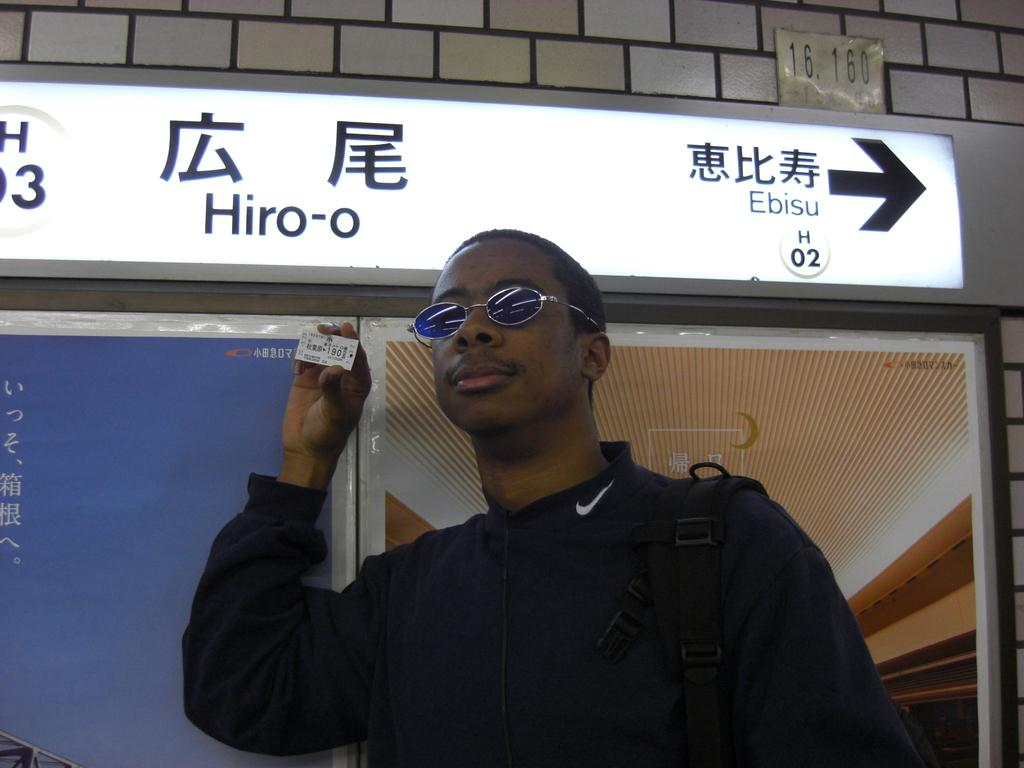Who or what is present in the image? There is a person in the image. What can be observed about the person's attire? The person is wearing clothes and sunglasses. What is the person holding in the image? The person is holding a card. What can be seen on the wall in the image? There is a board on the wall in the image. Can you hear the person coughing in the image? There is no audible information in the image, so it is not possible to determine if the person is coughing or not. 